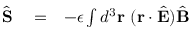Convert formula to latex. <formula><loc_0><loc_0><loc_500><loc_500>\begin{array} { r l r } { \hat { S } } & = } & { - \epsilon \int d ^ { 3 } { r } \ ( { r } \cdot \hat { E } ) \hat { B } } \end{array}</formula> 